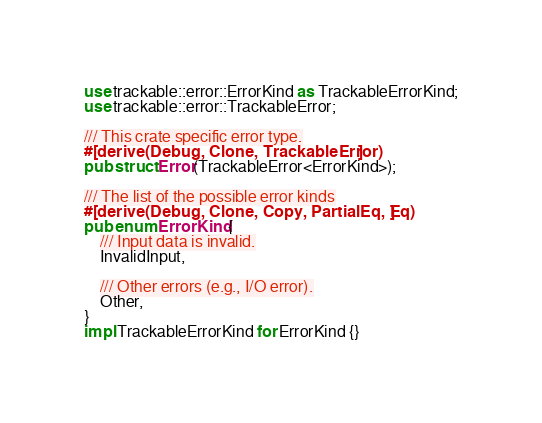Convert code to text. <code><loc_0><loc_0><loc_500><loc_500><_Rust_>use trackable::error::ErrorKind as TrackableErrorKind;
use trackable::error::TrackableError;

/// This crate specific error type.
#[derive(Debug, Clone, TrackableError)]
pub struct Error(TrackableError<ErrorKind>);

/// The list of the possible error kinds
#[derive(Debug, Clone, Copy, PartialEq, Eq)]
pub enum ErrorKind {
    /// Input data is invalid.
    InvalidInput,

    /// Other errors (e.g., I/O error).
    Other,
}
impl TrackableErrorKind for ErrorKind {}
</code> 